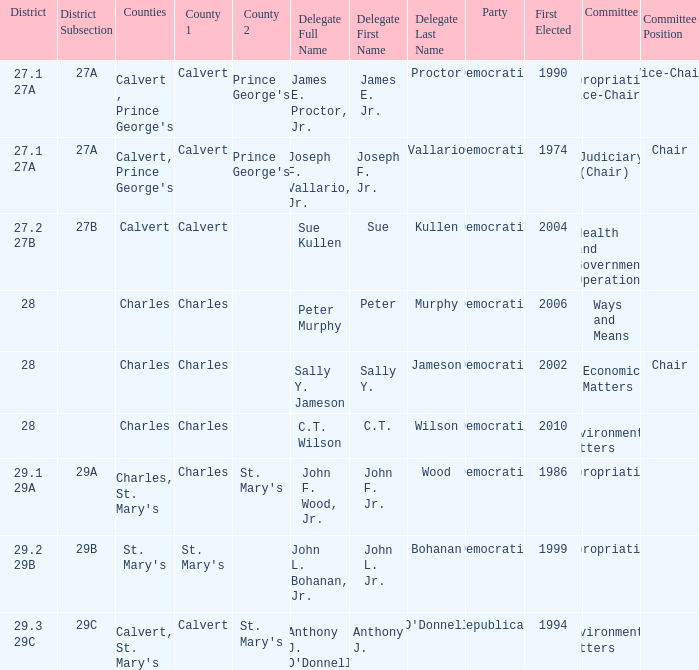Which was the district that had first elected greater than 2006 and is democratic? 28.0. 